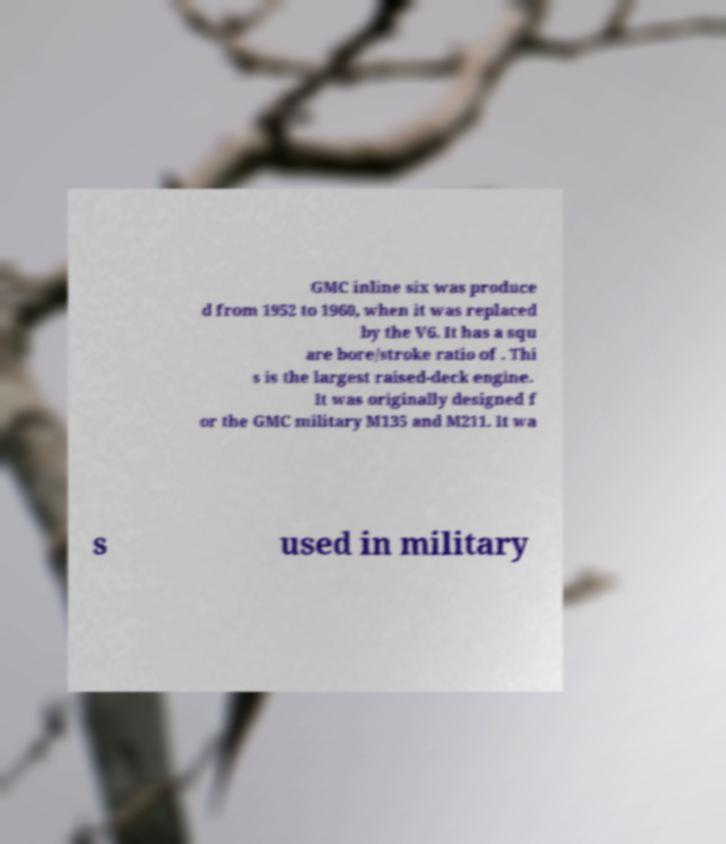Can you read and provide the text displayed in the image?This photo seems to have some interesting text. Can you extract and type it out for me? GMC inline six was produce d from 1952 to 1960, when it was replaced by the V6. It has a squ are bore/stroke ratio of . Thi s is the largest raised-deck engine. It was originally designed f or the GMC military M135 and M211. It wa s used in military 